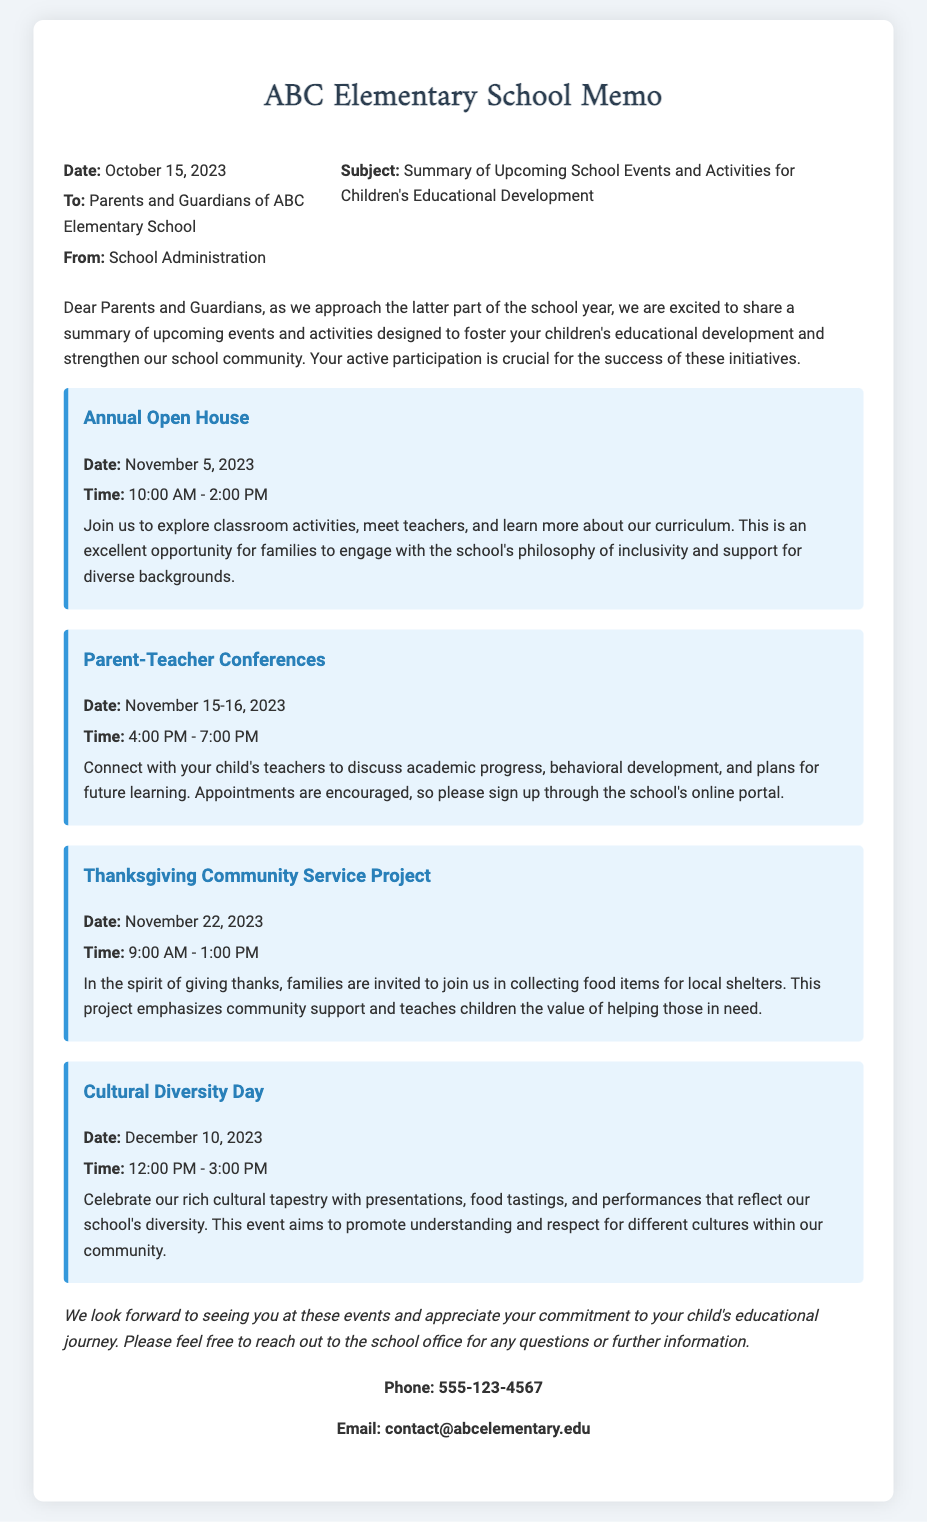What is the date of the Annual Open House? The Annual Open House is scheduled for November 5, 2023, as stated in the memo.
Answer: November 5, 2023 What is the time for the Parent-Teacher Conferences? The Parent-Teacher Conferences are from 4:00 PM to 7:00 PM on November 15-16, 2023.
Answer: 4:00 PM - 7:00 PM What event is taking place on November 22, 2023? The Thanksgiving Community Service Project is occurring on November 22, 2023, according to the document.
Answer: Thanksgiving Community Service Project How many events are listed in the memo? The memo lists four events designed to foster children's educational development.
Answer: Four What is the purpose of Cultural Diversity Day? The event aims to promote understanding and respect for different cultures within our community.
Answer: Promote understanding and respect for different cultures What should parents do to sign up for Parent-Teacher Conferences? Parents are encouraged to sign up through the school's online portal for appointments.
Answer: Sign up through the school's online portal What type of project is scheduled for Thanksgiving? The Thanksgiving activity is a community service project focused on collecting food items for local shelters.
Answer: Community service project What time does Cultural Diversity Day begin? Cultural Diversity Day starts at 12:00 PM, as mentioned in the memo.
Answer: 12:00 PM 